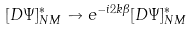<formula> <loc_0><loc_0><loc_500><loc_500>[ D \Psi ] _ { N M } ^ { * } \to e ^ { - i 2 k \beta } [ D \Psi ] _ { N M } ^ { * }</formula> 